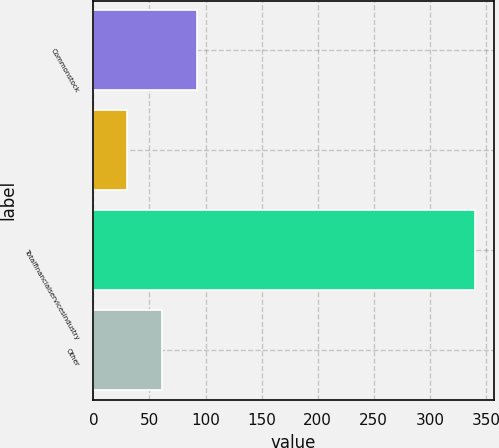<chart> <loc_0><loc_0><loc_500><loc_500><bar_chart><fcel>Commonstock<fcel>Unnamed: 1<fcel>Totalfinancialservicesindustry<fcel>Other<nl><fcel>92<fcel>30<fcel>340<fcel>61<nl></chart> 